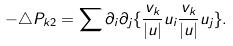<formula> <loc_0><loc_0><loc_500><loc_500>- \triangle P _ { k 2 } = \sum \partial _ { i } \partial _ { j } \{ \frac { v _ { k } } { | u | } u _ { i } \frac { v _ { k } } { | u | } u _ { j } \} .</formula> 